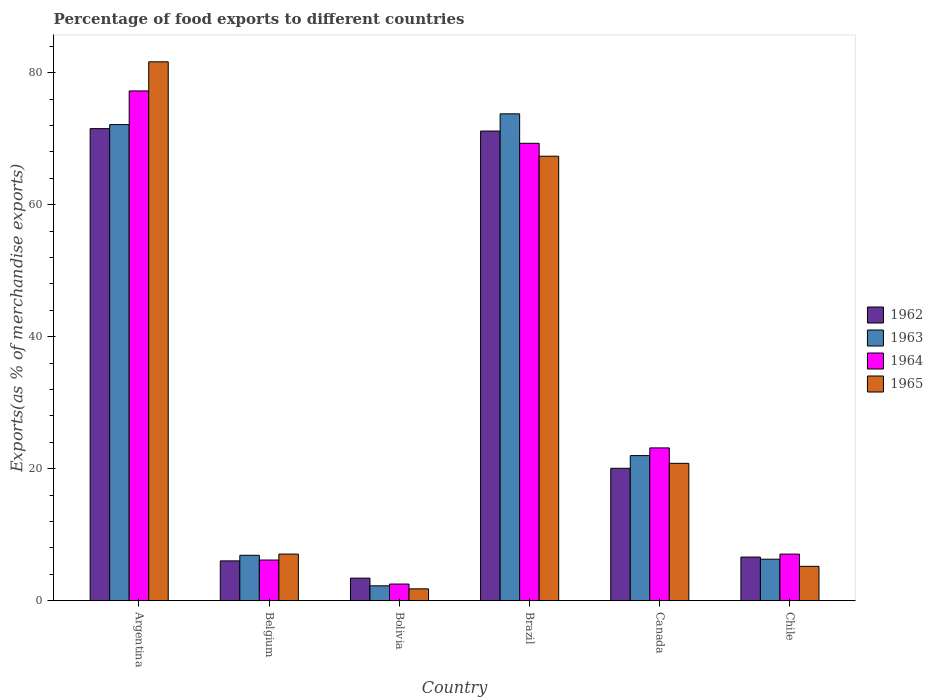How many groups of bars are there?
Give a very brief answer. 6. Are the number of bars per tick equal to the number of legend labels?
Keep it short and to the point. Yes. How many bars are there on the 3rd tick from the left?
Ensure brevity in your answer.  4. What is the percentage of exports to different countries in 1963 in Belgium?
Your response must be concise. 6.89. Across all countries, what is the maximum percentage of exports to different countries in 1963?
Ensure brevity in your answer.  73.76. Across all countries, what is the minimum percentage of exports to different countries in 1963?
Offer a very short reply. 2.27. In which country was the percentage of exports to different countries in 1965 maximum?
Offer a terse response. Argentina. In which country was the percentage of exports to different countries in 1962 minimum?
Offer a very short reply. Bolivia. What is the total percentage of exports to different countries in 1965 in the graph?
Offer a very short reply. 183.89. What is the difference between the percentage of exports to different countries in 1964 in Canada and that in Chile?
Your answer should be compact. 16.09. What is the difference between the percentage of exports to different countries in 1965 in Brazil and the percentage of exports to different countries in 1962 in Belgium?
Make the answer very short. 61.3. What is the average percentage of exports to different countries in 1962 per country?
Your response must be concise. 29.8. What is the difference between the percentage of exports to different countries of/in 1962 and percentage of exports to different countries of/in 1963 in Bolivia?
Your response must be concise. 1.16. In how many countries, is the percentage of exports to different countries in 1962 greater than 20 %?
Offer a terse response. 3. What is the ratio of the percentage of exports to different countries in 1963 in Belgium to that in Brazil?
Offer a terse response. 0.09. What is the difference between the highest and the second highest percentage of exports to different countries in 1962?
Your response must be concise. -51.08. What is the difference between the highest and the lowest percentage of exports to different countries in 1962?
Offer a terse response. 68.09. In how many countries, is the percentage of exports to different countries in 1963 greater than the average percentage of exports to different countries in 1963 taken over all countries?
Your answer should be compact. 2. Is it the case that in every country, the sum of the percentage of exports to different countries in 1962 and percentage of exports to different countries in 1964 is greater than the sum of percentage of exports to different countries in 1965 and percentage of exports to different countries in 1963?
Keep it short and to the point. No. What does the 1st bar from the left in Chile represents?
Give a very brief answer. 1962. What does the 2nd bar from the right in Brazil represents?
Offer a very short reply. 1964. How many bars are there?
Provide a short and direct response. 24. Are the values on the major ticks of Y-axis written in scientific E-notation?
Ensure brevity in your answer.  No. Does the graph contain grids?
Make the answer very short. No. How many legend labels are there?
Your answer should be very brief. 4. What is the title of the graph?
Give a very brief answer. Percentage of food exports to different countries. What is the label or title of the X-axis?
Your answer should be very brief. Country. What is the label or title of the Y-axis?
Provide a short and direct response. Exports(as % of merchandise exports). What is the Exports(as % of merchandise exports) in 1962 in Argentina?
Offer a terse response. 71.52. What is the Exports(as % of merchandise exports) in 1963 in Argentina?
Offer a very short reply. 72.12. What is the Exports(as % of merchandise exports) of 1964 in Argentina?
Keep it short and to the point. 77.23. What is the Exports(as % of merchandise exports) in 1965 in Argentina?
Your answer should be very brief. 81.64. What is the Exports(as % of merchandise exports) of 1962 in Belgium?
Your answer should be very brief. 6.04. What is the Exports(as % of merchandise exports) of 1963 in Belgium?
Your answer should be very brief. 6.89. What is the Exports(as % of merchandise exports) in 1964 in Belgium?
Provide a short and direct response. 6.17. What is the Exports(as % of merchandise exports) of 1965 in Belgium?
Your answer should be compact. 7.07. What is the Exports(as % of merchandise exports) in 1962 in Bolivia?
Keep it short and to the point. 3.43. What is the Exports(as % of merchandise exports) of 1963 in Bolivia?
Offer a terse response. 2.27. What is the Exports(as % of merchandise exports) in 1964 in Bolivia?
Offer a very short reply. 2.53. What is the Exports(as % of merchandise exports) of 1965 in Bolivia?
Give a very brief answer. 1.81. What is the Exports(as % of merchandise exports) of 1962 in Brazil?
Provide a succinct answer. 71.15. What is the Exports(as % of merchandise exports) in 1963 in Brazil?
Give a very brief answer. 73.76. What is the Exports(as % of merchandise exports) in 1964 in Brazil?
Give a very brief answer. 69.29. What is the Exports(as % of merchandise exports) of 1965 in Brazil?
Your response must be concise. 67.34. What is the Exports(as % of merchandise exports) in 1962 in Canada?
Your answer should be very brief. 20.07. What is the Exports(as % of merchandise exports) in 1963 in Canada?
Ensure brevity in your answer.  21.99. What is the Exports(as % of merchandise exports) of 1964 in Canada?
Your answer should be very brief. 23.16. What is the Exports(as % of merchandise exports) in 1965 in Canada?
Offer a terse response. 20.82. What is the Exports(as % of merchandise exports) of 1962 in Chile?
Offer a very short reply. 6.62. What is the Exports(as % of merchandise exports) in 1963 in Chile?
Give a very brief answer. 6.3. What is the Exports(as % of merchandise exports) in 1964 in Chile?
Offer a terse response. 7.07. What is the Exports(as % of merchandise exports) of 1965 in Chile?
Your answer should be compact. 5.22. Across all countries, what is the maximum Exports(as % of merchandise exports) in 1962?
Provide a short and direct response. 71.52. Across all countries, what is the maximum Exports(as % of merchandise exports) of 1963?
Make the answer very short. 73.76. Across all countries, what is the maximum Exports(as % of merchandise exports) in 1964?
Your response must be concise. 77.23. Across all countries, what is the maximum Exports(as % of merchandise exports) of 1965?
Keep it short and to the point. 81.64. Across all countries, what is the minimum Exports(as % of merchandise exports) of 1962?
Your answer should be very brief. 3.43. Across all countries, what is the minimum Exports(as % of merchandise exports) of 1963?
Your answer should be compact. 2.27. Across all countries, what is the minimum Exports(as % of merchandise exports) in 1964?
Your answer should be compact. 2.53. Across all countries, what is the minimum Exports(as % of merchandise exports) of 1965?
Provide a succinct answer. 1.81. What is the total Exports(as % of merchandise exports) of 1962 in the graph?
Ensure brevity in your answer.  178.83. What is the total Exports(as % of merchandise exports) of 1963 in the graph?
Ensure brevity in your answer.  183.33. What is the total Exports(as % of merchandise exports) in 1964 in the graph?
Give a very brief answer. 185.45. What is the total Exports(as % of merchandise exports) in 1965 in the graph?
Your answer should be very brief. 183.89. What is the difference between the Exports(as % of merchandise exports) in 1962 in Argentina and that in Belgium?
Your answer should be compact. 65.47. What is the difference between the Exports(as % of merchandise exports) of 1963 in Argentina and that in Belgium?
Offer a very short reply. 65.23. What is the difference between the Exports(as % of merchandise exports) in 1964 in Argentina and that in Belgium?
Provide a succinct answer. 71.06. What is the difference between the Exports(as % of merchandise exports) in 1965 in Argentina and that in Belgium?
Your answer should be compact. 74.56. What is the difference between the Exports(as % of merchandise exports) in 1962 in Argentina and that in Bolivia?
Keep it short and to the point. 68.09. What is the difference between the Exports(as % of merchandise exports) in 1963 in Argentina and that in Bolivia?
Make the answer very short. 69.86. What is the difference between the Exports(as % of merchandise exports) in 1964 in Argentina and that in Bolivia?
Offer a terse response. 74.69. What is the difference between the Exports(as % of merchandise exports) of 1965 in Argentina and that in Bolivia?
Keep it short and to the point. 79.83. What is the difference between the Exports(as % of merchandise exports) in 1962 in Argentina and that in Brazil?
Provide a succinct answer. 0.37. What is the difference between the Exports(as % of merchandise exports) in 1963 in Argentina and that in Brazil?
Make the answer very short. -1.63. What is the difference between the Exports(as % of merchandise exports) in 1964 in Argentina and that in Brazil?
Make the answer very short. 7.93. What is the difference between the Exports(as % of merchandise exports) in 1965 in Argentina and that in Brazil?
Your response must be concise. 14.3. What is the difference between the Exports(as % of merchandise exports) in 1962 in Argentina and that in Canada?
Give a very brief answer. 51.45. What is the difference between the Exports(as % of merchandise exports) in 1963 in Argentina and that in Canada?
Keep it short and to the point. 50.13. What is the difference between the Exports(as % of merchandise exports) of 1964 in Argentina and that in Canada?
Your answer should be compact. 54.07. What is the difference between the Exports(as % of merchandise exports) in 1965 in Argentina and that in Canada?
Your answer should be very brief. 60.82. What is the difference between the Exports(as % of merchandise exports) of 1962 in Argentina and that in Chile?
Your answer should be very brief. 64.9. What is the difference between the Exports(as % of merchandise exports) in 1963 in Argentina and that in Chile?
Ensure brevity in your answer.  65.83. What is the difference between the Exports(as % of merchandise exports) in 1964 in Argentina and that in Chile?
Provide a short and direct response. 70.16. What is the difference between the Exports(as % of merchandise exports) of 1965 in Argentina and that in Chile?
Offer a terse response. 76.42. What is the difference between the Exports(as % of merchandise exports) of 1962 in Belgium and that in Bolivia?
Keep it short and to the point. 2.61. What is the difference between the Exports(as % of merchandise exports) of 1963 in Belgium and that in Bolivia?
Your answer should be very brief. 4.62. What is the difference between the Exports(as % of merchandise exports) in 1964 in Belgium and that in Bolivia?
Offer a very short reply. 3.64. What is the difference between the Exports(as % of merchandise exports) in 1965 in Belgium and that in Bolivia?
Provide a succinct answer. 5.27. What is the difference between the Exports(as % of merchandise exports) of 1962 in Belgium and that in Brazil?
Offer a terse response. -65.11. What is the difference between the Exports(as % of merchandise exports) of 1963 in Belgium and that in Brazil?
Give a very brief answer. -66.87. What is the difference between the Exports(as % of merchandise exports) in 1964 in Belgium and that in Brazil?
Your response must be concise. -63.12. What is the difference between the Exports(as % of merchandise exports) in 1965 in Belgium and that in Brazil?
Your response must be concise. -60.27. What is the difference between the Exports(as % of merchandise exports) in 1962 in Belgium and that in Canada?
Offer a very short reply. -14.02. What is the difference between the Exports(as % of merchandise exports) in 1963 in Belgium and that in Canada?
Ensure brevity in your answer.  -15.1. What is the difference between the Exports(as % of merchandise exports) of 1964 in Belgium and that in Canada?
Provide a short and direct response. -16.99. What is the difference between the Exports(as % of merchandise exports) in 1965 in Belgium and that in Canada?
Keep it short and to the point. -13.75. What is the difference between the Exports(as % of merchandise exports) of 1962 in Belgium and that in Chile?
Make the answer very short. -0.58. What is the difference between the Exports(as % of merchandise exports) in 1963 in Belgium and that in Chile?
Provide a short and direct response. 0.59. What is the difference between the Exports(as % of merchandise exports) in 1964 in Belgium and that in Chile?
Your answer should be compact. -0.9. What is the difference between the Exports(as % of merchandise exports) in 1965 in Belgium and that in Chile?
Provide a succinct answer. 1.86. What is the difference between the Exports(as % of merchandise exports) of 1962 in Bolivia and that in Brazil?
Offer a very short reply. -67.72. What is the difference between the Exports(as % of merchandise exports) in 1963 in Bolivia and that in Brazil?
Make the answer very short. -71.49. What is the difference between the Exports(as % of merchandise exports) of 1964 in Bolivia and that in Brazil?
Give a very brief answer. -66.76. What is the difference between the Exports(as % of merchandise exports) of 1965 in Bolivia and that in Brazil?
Ensure brevity in your answer.  -65.53. What is the difference between the Exports(as % of merchandise exports) in 1962 in Bolivia and that in Canada?
Make the answer very short. -16.64. What is the difference between the Exports(as % of merchandise exports) of 1963 in Bolivia and that in Canada?
Give a very brief answer. -19.72. What is the difference between the Exports(as % of merchandise exports) in 1964 in Bolivia and that in Canada?
Offer a very short reply. -20.62. What is the difference between the Exports(as % of merchandise exports) in 1965 in Bolivia and that in Canada?
Your answer should be compact. -19.01. What is the difference between the Exports(as % of merchandise exports) in 1962 in Bolivia and that in Chile?
Provide a succinct answer. -3.19. What is the difference between the Exports(as % of merchandise exports) in 1963 in Bolivia and that in Chile?
Your answer should be very brief. -4.03. What is the difference between the Exports(as % of merchandise exports) in 1964 in Bolivia and that in Chile?
Offer a very short reply. -4.54. What is the difference between the Exports(as % of merchandise exports) of 1965 in Bolivia and that in Chile?
Offer a very short reply. -3.41. What is the difference between the Exports(as % of merchandise exports) of 1962 in Brazil and that in Canada?
Give a very brief answer. 51.08. What is the difference between the Exports(as % of merchandise exports) of 1963 in Brazil and that in Canada?
Your answer should be compact. 51.77. What is the difference between the Exports(as % of merchandise exports) of 1964 in Brazil and that in Canada?
Offer a terse response. 46.14. What is the difference between the Exports(as % of merchandise exports) of 1965 in Brazil and that in Canada?
Your answer should be compact. 46.52. What is the difference between the Exports(as % of merchandise exports) of 1962 in Brazil and that in Chile?
Your response must be concise. 64.53. What is the difference between the Exports(as % of merchandise exports) in 1963 in Brazil and that in Chile?
Provide a succinct answer. 67.46. What is the difference between the Exports(as % of merchandise exports) in 1964 in Brazil and that in Chile?
Ensure brevity in your answer.  62.22. What is the difference between the Exports(as % of merchandise exports) in 1965 in Brazil and that in Chile?
Ensure brevity in your answer.  62.12. What is the difference between the Exports(as % of merchandise exports) of 1962 in Canada and that in Chile?
Make the answer very short. 13.45. What is the difference between the Exports(as % of merchandise exports) in 1963 in Canada and that in Chile?
Ensure brevity in your answer.  15.69. What is the difference between the Exports(as % of merchandise exports) of 1964 in Canada and that in Chile?
Make the answer very short. 16.09. What is the difference between the Exports(as % of merchandise exports) of 1965 in Canada and that in Chile?
Keep it short and to the point. 15.6. What is the difference between the Exports(as % of merchandise exports) of 1962 in Argentina and the Exports(as % of merchandise exports) of 1963 in Belgium?
Your answer should be compact. 64.63. What is the difference between the Exports(as % of merchandise exports) in 1962 in Argentina and the Exports(as % of merchandise exports) in 1964 in Belgium?
Give a very brief answer. 65.35. What is the difference between the Exports(as % of merchandise exports) in 1962 in Argentina and the Exports(as % of merchandise exports) in 1965 in Belgium?
Ensure brevity in your answer.  64.44. What is the difference between the Exports(as % of merchandise exports) of 1963 in Argentina and the Exports(as % of merchandise exports) of 1964 in Belgium?
Provide a succinct answer. 65.95. What is the difference between the Exports(as % of merchandise exports) of 1963 in Argentina and the Exports(as % of merchandise exports) of 1965 in Belgium?
Provide a succinct answer. 65.05. What is the difference between the Exports(as % of merchandise exports) of 1964 in Argentina and the Exports(as % of merchandise exports) of 1965 in Belgium?
Provide a short and direct response. 70.15. What is the difference between the Exports(as % of merchandise exports) of 1962 in Argentina and the Exports(as % of merchandise exports) of 1963 in Bolivia?
Provide a succinct answer. 69.25. What is the difference between the Exports(as % of merchandise exports) in 1962 in Argentina and the Exports(as % of merchandise exports) in 1964 in Bolivia?
Your answer should be compact. 68.98. What is the difference between the Exports(as % of merchandise exports) of 1962 in Argentina and the Exports(as % of merchandise exports) of 1965 in Bolivia?
Your response must be concise. 69.71. What is the difference between the Exports(as % of merchandise exports) of 1963 in Argentina and the Exports(as % of merchandise exports) of 1964 in Bolivia?
Offer a terse response. 69.59. What is the difference between the Exports(as % of merchandise exports) of 1963 in Argentina and the Exports(as % of merchandise exports) of 1965 in Bolivia?
Keep it short and to the point. 70.32. What is the difference between the Exports(as % of merchandise exports) of 1964 in Argentina and the Exports(as % of merchandise exports) of 1965 in Bolivia?
Offer a terse response. 75.42. What is the difference between the Exports(as % of merchandise exports) of 1962 in Argentina and the Exports(as % of merchandise exports) of 1963 in Brazil?
Offer a terse response. -2.24. What is the difference between the Exports(as % of merchandise exports) in 1962 in Argentina and the Exports(as % of merchandise exports) in 1964 in Brazil?
Your answer should be compact. 2.22. What is the difference between the Exports(as % of merchandise exports) of 1962 in Argentina and the Exports(as % of merchandise exports) of 1965 in Brazil?
Your answer should be very brief. 4.18. What is the difference between the Exports(as % of merchandise exports) of 1963 in Argentina and the Exports(as % of merchandise exports) of 1964 in Brazil?
Ensure brevity in your answer.  2.83. What is the difference between the Exports(as % of merchandise exports) in 1963 in Argentina and the Exports(as % of merchandise exports) in 1965 in Brazil?
Provide a succinct answer. 4.79. What is the difference between the Exports(as % of merchandise exports) in 1964 in Argentina and the Exports(as % of merchandise exports) in 1965 in Brazil?
Offer a terse response. 9.89. What is the difference between the Exports(as % of merchandise exports) of 1962 in Argentina and the Exports(as % of merchandise exports) of 1963 in Canada?
Your response must be concise. 49.53. What is the difference between the Exports(as % of merchandise exports) in 1962 in Argentina and the Exports(as % of merchandise exports) in 1964 in Canada?
Give a very brief answer. 48.36. What is the difference between the Exports(as % of merchandise exports) in 1962 in Argentina and the Exports(as % of merchandise exports) in 1965 in Canada?
Provide a short and direct response. 50.7. What is the difference between the Exports(as % of merchandise exports) of 1963 in Argentina and the Exports(as % of merchandise exports) of 1964 in Canada?
Keep it short and to the point. 48.97. What is the difference between the Exports(as % of merchandise exports) of 1963 in Argentina and the Exports(as % of merchandise exports) of 1965 in Canada?
Provide a short and direct response. 51.31. What is the difference between the Exports(as % of merchandise exports) in 1964 in Argentina and the Exports(as % of merchandise exports) in 1965 in Canada?
Give a very brief answer. 56.41. What is the difference between the Exports(as % of merchandise exports) of 1962 in Argentina and the Exports(as % of merchandise exports) of 1963 in Chile?
Your answer should be very brief. 65.22. What is the difference between the Exports(as % of merchandise exports) of 1962 in Argentina and the Exports(as % of merchandise exports) of 1964 in Chile?
Offer a terse response. 64.45. What is the difference between the Exports(as % of merchandise exports) in 1962 in Argentina and the Exports(as % of merchandise exports) in 1965 in Chile?
Ensure brevity in your answer.  66.3. What is the difference between the Exports(as % of merchandise exports) of 1963 in Argentina and the Exports(as % of merchandise exports) of 1964 in Chile?
Offer a terse response. 65.05. What is the difference between the Exports(as % of merchandise exports) in 1963 in Argentina and the Exports(as % of merchandise exports) in 1965 in Chile?
Offer a terse response. 66.91. What is the difference between the Exports(as % of merchandise exports) of 1964 in Argentina and the Exports(as % of merchandise exports) of 1965 in Chile?
Ensure brevity in your answer.  72.01. What is the difference between the Exports(as % of merchandise exports) of 1962 in Belgium and the Exports(as % of merchandise exports) of 1963 in Bolivia?
Your answer should be compact. 3.78. What is the difference between the Exports(as % of merchandise exports) in 1962 in Belgium and the Exports(as % of merchandise exports) in 1964 in Bolivia?
Provide a short and direct response. 3.51. What is the difference between the Exports(as % of merchandise exports) of 1962 in Belgium and the Exports(as % of merchandise exports) of 1965 in Bolivia?
Your answer should be very brief. 4.24. What is the difference between the Exports(as % of merchandise exports) in 1963 in Belgium and the Exports(as % of merchandise exports) in 1964 in Bolivia?
Give a very brief answer. 4.36. What is the difference between the Exports(as % of merchandise exports) of 1963 in Belgium and the Exports(as % of merchandise exports) of 1965 in Bolivia?
Keep it short and to the point. 5.08. What is the difference between the Exports(as % of merchandise exports) of 1964 in Belgium and the Exports(as % of merchandise exports) of 1965 in Bolivia?
Offer a very short reply. 4.36. What is the difference between the Exports(as % of merchandise exports) of 1962 in Belgium and the Exports(as % of merchandise exports) of 1963 in Brazil?
Offer a very short reply. -67.71. What is the difference between the Exports(as % of merchandise exports) in 1962 in Belgium and the Exports(as % of merchandise exports) in 1964 in Brazil?
Your answer should be compact. -63.25. What is the difference between the Exports(as % of merchandise exports) of 1962 in Belgium and the Exports(as % of merchandise exports) of 1965 in Brazil?
Your response must be concise. -61.3. What is the difference between the Exports(as % of merchandise exports) in 1963 in Belgium and the Exports(as % of merchandise exports) in 1964 in Brazil?
Ensure brevity in your answer.  -62.4. What is the difference between the Exports(as % of merchandise exports) in 1963 in Belgium and the Exports(as % of merchandise exports) in 1965 in Brazil?
Your response must be concise. -60.45. What is the difference between the Exports(as % of merchandise exports) of 1964 in Belgium and the Exports(as % of merchandise exports) of 1965 in Brazil?
Provide a short and direct response. -61.17. What is the difference between the Exports(as % of merchandise exports) of 1962 in Belgium and the Exports(as % of merchandise exports) of 1963 in Canada?
Your answer should be compact. -15.95. What is the difference between the Exports(as % of merchandise exports) in 1962 in Belgium and the Exports(as % of merchandise exports) in 1964 in Canada?
Provide a succinct answer. -17.11. What is the difference between the Exports(as % of merchandise exports) of 1962 in Belgium and the Exports(as % of merchandise exports) of 1965 in Canada?
Ensure brevity in your answer.  -14.78. What is the difference between the Exports(as % of merchandise exports) of 1963 in Belgium and the Exports(as % of merchandise exports) of 1964 in Canada?
Offer a terse response. -16.27. What is the difference between the Exports(as % of merchandise exports) in 1963 in Belgium and the Exports(as % of merchandise exports) in 1965 in Canada?
Offer a very short reply. -13.93. What is the difference between the Exports(as % of merchandise exports) in 1964 in Belgium and the Exports(as % of merchandise exports) in 1965 in Canada?
Your answer should be very brief. -14.65. What is the difference between the Exports(as % of merchandise exports) of 1962 in Belgium and the Exports(as % of merchandise exports) of 1963 in Chile?
Provide a succinct answer. -0.26. What is the difference between the Exports(as % of merchandise exports) of 1962 in Belgium and the Exports(as % of merchandise exports) of 1964 in Chile?
Your answer should be very brief. -1.03. What is the difference between the Exports(as % of merchandise exports) in 1962 in Belgium and the Exports(as % of merchandise exports) in 1965 in Chile?
Make the answer very short. 0.83. What is the difference between the Exports(as % of merchandise exports) of 1963 in Belgium and the Exports(as % of merchandise exports) of 1964 in Chile?
Ensure brevity in your answer.  -0.18. What is the difference between the Exports(as % of merchandise exports) in 1963 in Belgium and the Exports(as % of merchandise exports) in 1965 in Chile?
Keep it short and to the point. 1.67. What is the difference between the Exports(as % of merchandise exports) in 1964 in Belgium and the Exports(as % of merchandise exports) in 1965 in Chile?
Provide a short and direct response. 0.95. What is the difference between the Exports(as % of merchandise exports) of 1962 in Bolivia and the Exports(as % of merchandise exports) of 1963 in Brazil?
Make the answer very short. -70.33. What is the difference between the Exports(as % of merchandise exports) in 1962 in Bolivia and the Exports(as % of merchandise exports) in 1964 in Brazil?
Offer a terse response. -65.86. What is the difference between the Exports(as % of merchandise exports) of 1962 in Bolivia and the Exports(as % of merchandise exports) of 1965 in Brazil?
Provide a succinct answer. -63.91. What is the difference between the Exports(as % of merchandise exports) in 1963 in Bolivia and the Exports(as % of merchandise exports) in 1964 in Brazil?
Keep it short and to the point. -67.03. What is the difference between the Exports(as % of merchandise exports) of 1963 in Bolivia and the Exports(as % of merchandise exports) of 1965 in Brazil?
Offer a terse response. -65.07. What is the difference between the Exports(as % of merchandise exports) in 1964 in Bolivia and the Exports(as % of merchandise exports) in 1965 in Brazil?
Keep it short and to the point. -64.81. What is the difference between the Exports(as % of merchandise exports) of 1962 in Bolivia and the Exports(as % of merchandise exports) of 1963 in Canada?
Offer a terse response. -18.56. What is the difference between the Exports(as % of merchandise exports) of 1962 in Bolivia and the Exports(as % of merchandise exports) of 1964 in Canada?
Keep it short and to the point. -19.73. What is the difference between the Exports(as % of merchandise exports) in 1962 in Bolivia and the Exports(as % of merchandise exports) in 1965 in Canada?
Your answer should be compact. -17.39. What is the difference between the Exports(as % of merchandise exports) of 1963 in Bolivia and the Exports(as % of merchandise exports) of 1964 in Canada?
Offer a terse response. -20.89. What is the difference between the Exports(as % of merchandise exports) of 1963 in Bolivia and the Exports(as % of merchandise exports) of 1965 in Canada?
Offer a very short reply. -18.55. What is the difference between the Exports(as % of merchandise exports) of 1964 in Bolivia and the Exports(as % of merchandise exports) of 1965 in Canada?
Make the answer very short. -18.29. What is the difference between the Exports(as % of merchandise exports) in 1962 in Bolivia and the Exports(as % of merchandise exports) in 1963 in Chile?
Offer a very short reply. -2.87. What is the difference between the Exports(as % of merchandise exports) of 1962 in Bolivia and the Exports(as % of merchandise exports) of 1964 in Chile?
Provide a succinct answer. -3.64. What is the difference between the Exports(as % of merchandise exports) in 1962 in Bolivia and the Exports(as % of merchandise exports) in 1965 in Chile?
Make the answer very short. -1.79. What is the difference between the Exports(as % of merchandise exports) of 1963 in Bolivia and the Exports(as % of merchandise exports) of 1964 in Chile?
Provide a short and direct response. -4.8. What is the difference between the Exports(as % of merchandise exports) of 1963 in Bolivia and the Exports(as % of merchandise exports) of 1965 in Chile?
Ensure brevity in your answer.  -2.95. What is the difference between the Exports(as % of merchandise exports) in 1964 in Bolivia and the Exports(as % of merchandise exports) in 1965 in Chile?
Provide a succinct answer. -2.69. What is the difference between the Exports(as % of merchandise exports) of 1962 in Brazil and the Exports(as % of merchandise exports) of 1963 in Canada?
Offer a terse response. 49.16. What is the difference between the Exports(as % of merchandise exports) in 1962 in Brazil and the Exports(as % of merchandise exports) in 1964 in Canada?
Keep it short and to the point. 47.99. What is the difference between the Exports(as % of merchandise exports) in 1962 in Brazil and the Exports(as % of merchandise exports) in 1965 in Canada?
Make the answer very short. 50.33. What is the difference between the Exports(as % of merchandise exports) in 1963 in Brazil and the Exports(as % of merchandise exports) in 1964 in Canada?
Your answer should be very brief. 50.6. What is the difference between the Exports(as % of merchandise exports) of 1963 in Brazil and the Exports(as % of merchandise exports) of 1965 in Canada?
Make the answer very short. 52.94. What is the difference between the Exports(as % of merchandise exports) in 1964 in Brazil and the Exports(as % of merchandise exports) in 1965 in Canada?
Offer a very short reply. 48.48. What is the difference between the Exports(as % of merchandise exports) of 1962 in Brazil and the Exports(as % of merchandise exports) of 1963 in Chile?
Your answer should be compact. 64.85. What is the difference between the Exports(as % of merchandise exports) in 1962 in Brazil and the Exports(as % of merchandise exports) in 1964 in Chile?
Provide a short and direct response. 64.08. What is the difference between the Exports(as % of merchandise exports) of 1962 in Brazil and the Exports(as % of merchandise exports) of 1965 in Chile?
Ensure brevity in your answer.  65.93. What is the difference between the Exports(as % of merchandise exports) in 1963 in Brazil and the Exports(as % of merchandise exports) in 1964 in Chile?
Keep it short and to the point. 66.69. What is the difference between the Exports(as % of merchandise exports) in 1963 in Brazil and the Exports(as % of merchandise exports) in 1965 in Chile?
Provide a succinct answer. 68.54. What is the difference between the Exports(as % of merchandise exports) of 1964 in Brazil and the Exports(as % of merchandise exports) of 1965 in Chile?
Ensure brevity in your answer.  64.08. What is the difference between the Exports(as % of merchandise exports) of 1962 in Canada and the Exports(as % of merchandise exports) of 1963 in Chile?
Keep it short and to the point. 13.77. What is the difference between the Exports(as % of merchandise exports) of 1962 in Canada and the Exports(as % of merchandise exports) of 1964 in Chile?
Ensure brevity in your answer.  13. What is the difference between the Exports(as % of merchandise exports) of 1962 in Canada and the Exports(as % of merchandise exports) of 1965 in Chile?
Make the answer very short. 14.85. What is the difference between the Exports(as % of merchandise exports) in 1963 in Canada and the Exports(as % of merchandise exports) in 1964 in Chile?
Offer a very short reply. 14.92. What is the difference between the Exports(as % of merchandise exports) in 1963 in Canada and the Exports(as % of merchandise exports) in 1965 in Chile?
Offer a very short reply. 16.77. What is the difference between the Exports(as % of merchandise exports) of 1964 in Canada and the Exports(as % of merchandise exports) of 1965 in Chile?
Give a very brief answer. 17.94. What is the average Exports(as % of merchandise exports) of 1962 per country?
Keep it short and to the point. 29.8. What is the average Exports(as % of merchandise exports) in 1963 per country?
Give a very brief answer. 30.55. What is the average Exports(as % of merchandise exports) of 1964 per country?
Offer a very short reply. 30.91. What is the average Exports(as % of merchandise exports) in 1965 per country?
Keep it short and to the point. 30.65. What is the difference between the Exports(as % of merchandise exports) in 1962 and Exports(as % of merchandise exports) in 1963 in Argentina?
Provide a short and direct response. -0.61. What is the difference between the Exports(as % of merchandise exports) in 1962 and Exports(as % of merchandise exports) in 1964 in Argentina?
Your answer should be compact. -5.71. What is the difference between the Exports(as % of merchandise exports) of 1962 and Exports(as % of merchandise exports) of 1965 in Argentina?
Your answer should be very brief. -10.12. What is the difference between the Exports(as % of merchandise exports) of 1963 and Exports(as % of merchandise exports) of 1964 in Argentina?
Your response must be concise. -5.1. What is the difference between the Exports(as % of merchandise exports) of 1963 and Exports(as % of merchandise exports) of 1965 in Argentina?
Make the answer very short. -9.51. What is the difference between the Exports(as % of merchandise exports) of 1964 and Exports(as % of merchandise exports) of 1965 in Argentina?
Offer a terse response. -4.41. What is the difference between the Exports(as % of merchandise exports) of 1962 and Exports(as % of merchandise exports) of 1963 in Belgium?
Your response must be concise. -0.85. What is the difference between the Exports(as % of merchandise exports) of 1962 and Exports(as % of merchandise exports) of 1964 in Belgium?
Your response must be concise. -0.13. What is the difference between the Exports(as % of merchandise exports) of 1962 and Exports(as % of merchandise exports) of 1965 in Belgium?
Offer a terse response. -1.03. What is the difference between the Exports(as % of merchandise exports) of 1963 and Exports(as % of merchandise exports) of 1964 in Belgium?
Provide a succinct answer. 0.72. What is the difference between the Exports(as % of merchandise exports) in 1963 and Exports(as % of merchandise exports) in 1965 in Belgium?
Your answer should be compact. -0.18. What is the difference between the Exports(as % of merchandise exports) of 1964 and Exports(as % of merchandise exports) of 1965 in Belgium?
Your response must be concise. -0.9. What is the difference between the Exports(as % of merchandise exports) in 1962 and Exports(as % of merchandise exports) in 1963 in Bolivia?
Give a very brief answer. 1.16. What is the difference between the Exports(as % of merchandise exports) of 1962 and Exports(as % of merchandise exports) of 1964 in Bolivia?
Your answer should be very brief. 0.9. What is the difference between the Exports(as % of merchandise exports) in 1962 and Exports(as % of merchandise exports) in 1965 in Bolivia?
Ensure brevity in your answer.  1.62. What is the difference between the Exports(as % of merchandise exports) in 1963 and Exports(as % of merchandise exports) in 1964 in Bolivia?
Provide a short and direct response. -0.27. What is the difference between the Exports(as % of merchandise exports) in 1963 and Exports(as % of merchandise exports) in 1965 in Bolivia?
Provide a succinct answer. 0.46. What is the difference between the Exports(as % of merchandise exports) in 1964 and Exports(as % of merchandise exports) in 1965 in Bolivia?
Your answer should be very brief. 0.73. What is the difference between the Exports(as % of merchandise exports) in 1962 and Exports(as % of merchandise exports) in 1963 in Brazil?
Provide a succinct answer. -2.61. What is the difference between the Exports(as % of merchandise exports) of 1962 and Exports(as % of merchandise exports) of 1964 in Brazil?
Offer a terse response. 1.86. What is the difference between the Exports(as % of merchandise exports) of 1962 and Exports(as % of merchandise exports) of 1965 in Brazil?
Your answer should be very brief. 3.81. What is the difference between the Exports(as % of merchandise exports) in 1963 and Exports(as % of merchandise exports) in 1964 in Brazil?
Your response must be concise. 4.46. What is the difference between the Exports(as % of merchandise exports) in 1963 and Exports(as % of merchandise exports) in 1965 in Brazil?
Your answer should be very brief. 6.42. What is the difference between the Exports(as % of merchandise exports) in 1964 and Exports(as % of merchandise exports) in 1965 in Brazil?
Your answer should be compact. 1.96. What is the difference between the Exports(as % of merchandise exports) of 1962 and Exports(as % of merchandise exports) of 1963 in Canada?
Give a very brief answer. -1.92. What is the difference between the Exports(as % of merchandise exports) of 1962 and Exports(as % of merchandise exports) of 1964 in Canada?
Provide a succinct answer. -3.09. What is the difference between the Exports(as % of merchandise exports) in 1962 and Exports(as % of merchandise exports) in 1965 in Canada?
Keep it short and to the point. -0.75. What is the difference between the Exports(as % of merchandise exports) of 1963 and Exports(as % of merchandise exports) of 1964 in Canada?
Your answer should be very brief. -1.17. What is the difference between the Exports(as % of merchandise exports) in 1963 and Exports(as % of merchandise exports) in 1965 in Canada?
Your response must be concise. 1.17. What is the difference between the Exports(as % of merchandise exports) in 1964 and Exports(as % of merchandise exports) in 1965 in Canada?
Offer a terse response. 2.34. What is the difference between the Exports(as % of merchandise exports) of 1962 and Exports(as % of merchandise exports) of 1963 in Chile?
Give a very brief answer. 0.32. What is the difference between the Exports(as % of merchandise exports) in 1962 and Exports(as % of merchandise exports) in 1964 in Chile?
Make the answer very short. -0.45. What is the difference between the Exports(as % of merchandise exports) of 1962 and Exports(as % of merchandise exports) of 1965 in Chile?
Provide a short and direct response. 1.4. What is the difference between the Exports(as % of merchandise exports) of 1963 and Exports(as % of merchandise exports) of 1964 in Chile?
Make the answer very short. -0.77. What is the difference between the Exports(as % of merchandise exports) of 1963 and Exports(as % of merchandise exports) of 1965 in Chile?
Provide a short and direct response. 1.08. What is the difference between the Exports(as % of merchandise exports) of 1964 and Exports(as % of merchandise exports) of 1965 in Chile?
Offer a terse response. 1.85. What is the ratio of the Exports(as % of merchandise exports) in 1962 in Argentina to that in Belgium?
Provide a short and direct response. 11.84. What is the ratio of the Exports(as % of merchandise exports) of 1963 in Argentina to that in Belgium?
Make the answer very short. 10.47. What is the ratio of the Exports(as % of merchandise exports) in 1964 in Argentina to that in Belgium?
Offer a very short reply. 12.52. What is the ratio of the Exports(as % of merchandise exports) of 1965 in Argentina to that in Belgium?
Your answer should be very brief. 11.54. What is the ratio of the Exports(as % of merchandise exports) in 1962 in Argentina to that in Bolivia?
Give a very brief answer. 20.86. What is the ratio of the Exports(as % of merchandise exports) in 1963 in Argentina to that in Bolivia?
Make the answer very short. 31.83. What is the ratio of the Exports(as % of merchandise exports) of 1964 in Argentina to that in Bolivia?
Make the answer very short. 30.5. What is the ratio of the Exports(as % of merchandise exports) of 1965 in Argentina to that in Bolivia?
Ensure brevity in your answer.  45.18. What is the ratio of the Exports(as % of merchandise exports) in 1963 in Argentina to that in Brazil?
Ensure brevity in your answer.  0.98. What is the ratio of the Exports(as % of merchandise exports) in 1964 in Argentina to that in Brazil?
Provide a succinct answer. 1.11. What is the ratio of the Exports(as % of merchandise exports) in 1965 in Argentina to that in Brazil?
Your response must be concise. 1.21. What is the ratio of the Exports(as % of merchandise exports) in 1962 in Argentina to that in Canada?
Ensure brevity in your answer.  3.56. What is the ratio of the Exports(as % of merchandise exports) in 1963 in Argentina to that in Canada?
Provide a short and direct response. 3.28. What is the ratio of the Exports(as % of merchandise exports) of 1964 in Argentina to that in Canada?
Keep it short and to the point. 3.34. What is the ratio of the Exports(as % of merchandise exports) in 1965 in Argentina to that in Canada?
Your answer should be very brief. 3.92. What is the ratio of the Exports(as % of merchandise exports) of 1962 in Argentina to that in Chile?
Your answer should be compact. 10.8. What is the ratio of the Exports(as % of merchandise exports) in 1963 in Argentina to that in Chile?
Offer a terse response. 11.45. What is the ratio of the Exports(as % of merchandise exports) in 1964 in Argentina to that in Chile?
Your answer should be very brief. 10.92. What is the ratio of the Exports(as % of merchandise exports) in 1965 in Argentina to that in Chile?
Give a very brief answer. 15.65. What is the ratio of the Exports(as % of merchandise exports) in 1962 in Belgium to that in Bolivia?
Make the answer very short. 1.76. What is the ratio of the Exports(as % of merchandise exports) of 1963 in Belgium to that in Bolivia?
Make the answer very short. 3.04. What is the ratio of the Exports(as % of merchandise exports) of 1964 in Belgium to that in Bolivia?
Your response must be concise. 2.44. What is the ratio of the Exports(as % of merchandise exports) in 1965 in Belgium to that in Bolivia?
Provide a short and direct response. 3.91. What is the ratio of the Exports(as % of merchandise exports) of 1962 in Belgium to that in Brazil?
Ensure brevity in your answer.  0.08. What is the ratio of the Exports(as % of merchandise exports) of 1963 in Belgium to that in Brazil?
Your response must be concise. 0.09. What is the ratio of the Exports(as % of merchandise exports) of 1964 in Belgium to that in Brazil?
Keep it short and to the point. 0.09. What is the ratio of the Exports(as % of merchandise exports) of 1965 in Belgium to that in Brazil?
Provide a succinct answer. 0.1. What is the ratio of the Exports(as % of merchandise exports) in 1962 in Belgium to that in Canada?
Keep it short and to the point. 0.3. What is the ratio of the Exports(as % of merchandise exports) in 1963 in Belgium to that in Canada?
Your response must be concise. 0.31. What is the ratio of the Exports(as % of merchandise exports) in 1964 in Belgium to that in Canada?
Give a very brief answer. 0.27. What is the ratio of the Exports(as % of merchandise exports) in 1965 in Belgium to that in Canada?
Offer a terse response. 0.34. What is the ratio of the Exports(as % of merchandise exports) of 1962 in Belgium to that in Chile?
Offer a very short reply. 0.91. What is the ratio of the Exports(as % of merchandise exports) in 1963 in Belgium to that in Chile?
Your answer should be very brief. 1.09. What is the ratio of the Exports(as % of merchandise exports) of 1964 in Belgium to that in Chile?
Offer a very short reply. 0.87. What is the ratio of the Exports(as % of merchandise exports) of 1965 in Belgium to that in Chile?
Keep it short and to the point. 1.36. What is the ratio of the Exports(as % of merchandise exports) of 1962 in Bolivia to that in Brazil?
Ensure brevity in your answer.  0.05. What is the ratio of the Exports(as % of merchandise exports) in 1963 in Bolivia to that in Brazil?
Your answer should be very brief. 0.03. What is the ratio of the Exports(as % of merchandise exports) of 1964 in Bolivia to that in Brazil?
Provide a succinct answer. 0.04. What is the ratio of the Exports(as % of merchandise exports) of 1965 in Bolivia to that in Brazil?
Offer a terse response. 0.03. What is the ratio of the Exports(as % of merchandise exports) of 1962 in Bolivia to that in Canada?
Your answer should be compact. 0.17. What is the ratio of the Exports(as % of merchandise exports) in 1963 in Bolivia to that in Canada?
Your answer should be compact. 0.1. What is the ratio of the Exports(as % of merchandise exports) in 1964 in Bolivia to that in Canada?
Offer a terse response. 0.11. What is the ratio of the Exports(as % of merchandise exports) of 1965 in Bolivia to that in Canada?
Provide a succinct answer. 0.09. What is the ratio of the Exports(as % of merchandise exports) of 1962 in Bolivia to that in Chile?
Provide a succinct answer. 0.52. What is the ratio of the Exports(as % of merchandise exports) of 1963 in Bolivia to that in Chile?
Give a very brief answer. 0.36. What is the ratio of the Exports(as % of merchandise exports) of 1964 in Bolivia to that in Chile?
Ensure brevity in your answer.  0.36. What is the ratio of the Exports(as % of merchandise exports) in 1965 in Bolivia to that in Chile?
Your answer should be very brief. 0.35. What is the ratio of the Exports(as % of merchandise exports) in 1962 in Brazil to that in Canada?
Give a very brief answer. 3.55. What is the ratio of the Exports(as % of merchandise exports) of 1963 in Brazil to that in Canada?
Ensure brevity in your answer.  3.35. What is the ratio of the Exports(as % of merchandise exports) in 1964 in Brazil to that in Canada?
Offer a terse response. 2.99. What is the ratio of the Exports(as % of merchandise exports) in 1965 in Brazil to that in Canada?
Ensure brevity in your answer.  3.23. What is the ratio of the Exports(as % of merchandise exports) of 1962 in Brazil to that in Chile?
Your response must be concise. 10.75. What is the ratio of the Exports(as % of merchandise exports) in 1963 in Brazil to that in Chile?
Your response must be concise. 11.71. What is the ratio of the Exports(as % of merchandise exports) of 1964 in Brazil to that in Chile?
Keep it short and to the point. 9.8. What is the ratio of the Exports(as % of merchandise exports) in 1965 in Brazil to that in Chile?
Give a very brief answer. 12.91. What is the ratio of the Exports(as % of merchandise exports) of 1962 in Canada to that in Chile?
Keep it short and to the point. 3.03. What is the ratio of the Exports(as % of merchandise exports) of 1963 in Canada to that in Chile?
Provide a succinct answer. 3.49. What is the ratio of the Exports(as % of merchandise exports) in 1964 in Canada to that in Chile?
Keep it short and to the point. 3.28. What is the ratio of the Exports(as % of merchandise exports) of 1965 in Canada to that in Chile?
Give a very brief answer. 3.99. What is the difference between the highest and the second highest Exports(as % of merchandise exports) in 1962?
Your answer should be very brief. 0.37. What is the difference between the highest and the second highest Exports(as % of merchandise exports) in 1963?
Provide a short and direct response. 1.63. What is the difference between the highest and the second highest Exports(as % of merchandise exports) of 1964?
Ensure brevity in your answer.  7.93. What is the difference between the highest and the second highest Exports(as % of merchandise exports) in 1965?
Your answer should be compact. 14.3. What is the difference between the highest and the lowest Exports(as % of merchandise exports) of 1962?
Provide a short and direct response. 68.09. What is the difference between the highest and the lowest Exports(as % of merchandise exports) in 1963?
Your response must be concise. 71.49. What is the difference between the highest and the lowest Exports(as % of merchandise exports) in 1964?
Your answer should be very brief. 74.69. What is the difference between the highest and the lowest Exports(as % of merchandise exports) of 1965?
Ensure brevity in your answer.  79.83. 